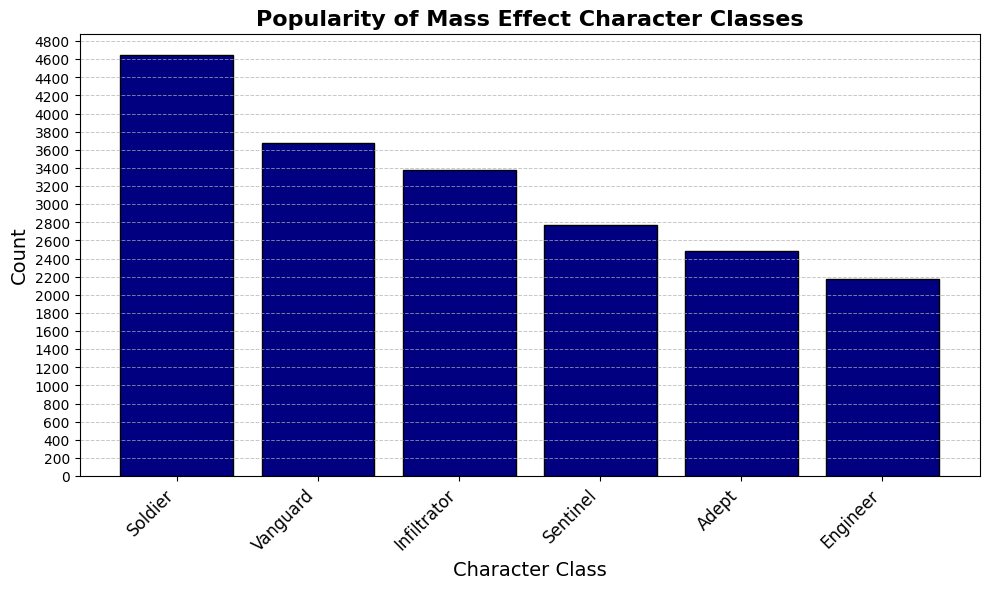Which character class is the most popular among Mass Effect players? The highest bar on the histogram represents the most popular character class, which is the Soldier class.
Answer: Soldier Which character class has the lowest popularity? The shortest bar on the histogram represents the least popular character class, which is the Engineer class.
Answer: Engineer How many more players choose the Soldier class compared to the Adept class? To find the difference, subtract the count of the Adept class from the count of the Soldier class. The count for Soldier is 4650, and for Adept, it is 2480. So, 4650 - 2480 = 2170.
Answer: 2170 Which two character classes have a combined count closest to 3500 players? By summing up counts of different pairs: Soldier (4650) and Vanguard (3670) are too high, but Infiltrator (3380) and Sentinel (2770) as well as Adept (2480) and Engineer (2170) are closer. Comparing these, Sentinel (2770) and Engineer (2170) combined is 3490, which is closest to 3500.
Answer: Adept and Engineer Are there more players who choose the Vanguard or the Sentinel class? Compare the heights of the Vanguard and Sentinel bars, Vanguard has 3670 while Sentinel has 2770.
Answer: Vanguard Is the Infiltrator class more popular than the Engineer class? Compare the heights of the Infiltrator and Engineer bars, the Infiltrator count is 3380 and the Engineer count is 2170.
Answer: Yes What is the average number of players for each character class? Sum up the counts of all classes and divide by the number of classes. Total count = 4650 (Soldier) + 3670 (Vanguard) + 3380 (Infiltrator) + 2770 (Sentinel) + 2170 (Engineer) + 2480 (Adept) = 19120. Number of classes = 6. Average = 19120 / 6 = 3187.
Answer: 3187 Divide the entire player base between Soldier and all other classes. What is the ratio of Soldier to non-Soldier players? Count for Soldier is 4650. Sum of counts for all other classes (3670 + 3380 + 2770 + 2170 + 2480) = 14470. Ratio = 4650 / 14470. To simplest form, 4650:14470 simplifies to approximately 1:3.1.
Answer: 1:3.1 If you merge the counts of Vanguard and Sentinel classes, how do they compare to the count of the Soldier class? Add the counts for Vanguard (3670) and Sentinel (2770), then compare to Soldier (4650). 3670 + 2770 = 6440, which is greater than 4650.
Answer: Greater 